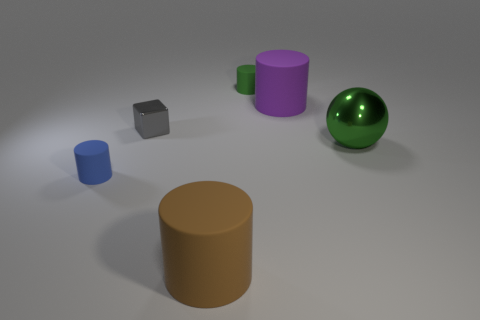What is the size of the green rubber cylinder?
Keep it short and to the point. Small. Are there more gray metal objects that are in front of the gray metallic object than gray balls?
Your response must be concise. No. Are there the same number of blue rubber things right of the large metallic object and small blue matte cylinders that are in front of the small blue matte thing?
Provide a succinct answer. Yes. The rubber cylinder that is in front of the tiny green cylinder and behind the large green shiny sphere is what color?
Give a very brief answer. Purple. Are there any other things that have the same size as the blue rubber cylinder?
Your answer should be compact. Yes. Is the number of large brown cylinders to the left of the blue object greater than the number of green matte objects that are to the left of the brown matte thing?
Keep it short and to the point. No. There is a metal object to the left of the purple matte object; is it the same size as the purple object?
Give a very brief answer. No. There is a large matte cylinder on the right side of the big matte object to the left of the big purple matte object; what number of gray metallic things are behind it?
Your answer should be very brief. 0. What is the size of the object that is in front of the gray object and behind the tiny blue cylinder?
Provide a succinct answer. Large. How many other objects are there of the same shape as the big green object?
Keep it short and to the point. 0. 